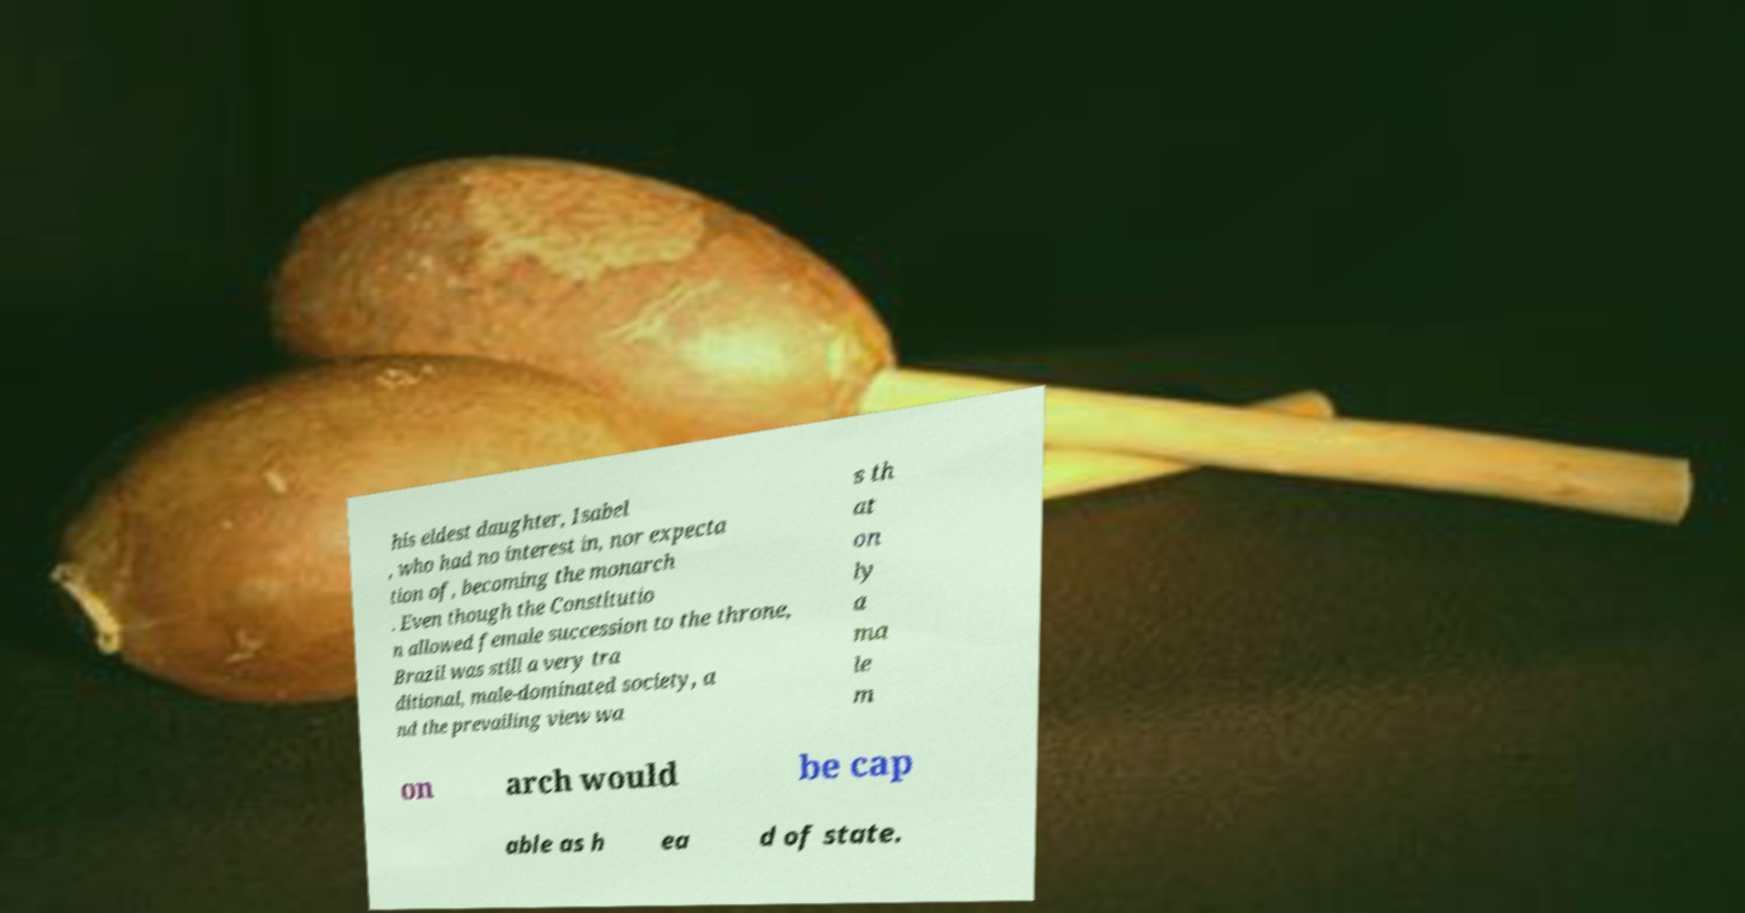Can you read and provide the text displayed in the image?This photo seems to have some interesting text. Can you extract and type it out for me? his eldest daughter, Isabel , who had no interest in, nor expecta tion of, becoming the monarch . Even though the Constitutio n allowed female succession to the throne, Brazil was still a very tra ditional, male-dominated society, a nd the prevailing view wa s th at on ly a ma le m on arch would be cap able as h ea d of state. 